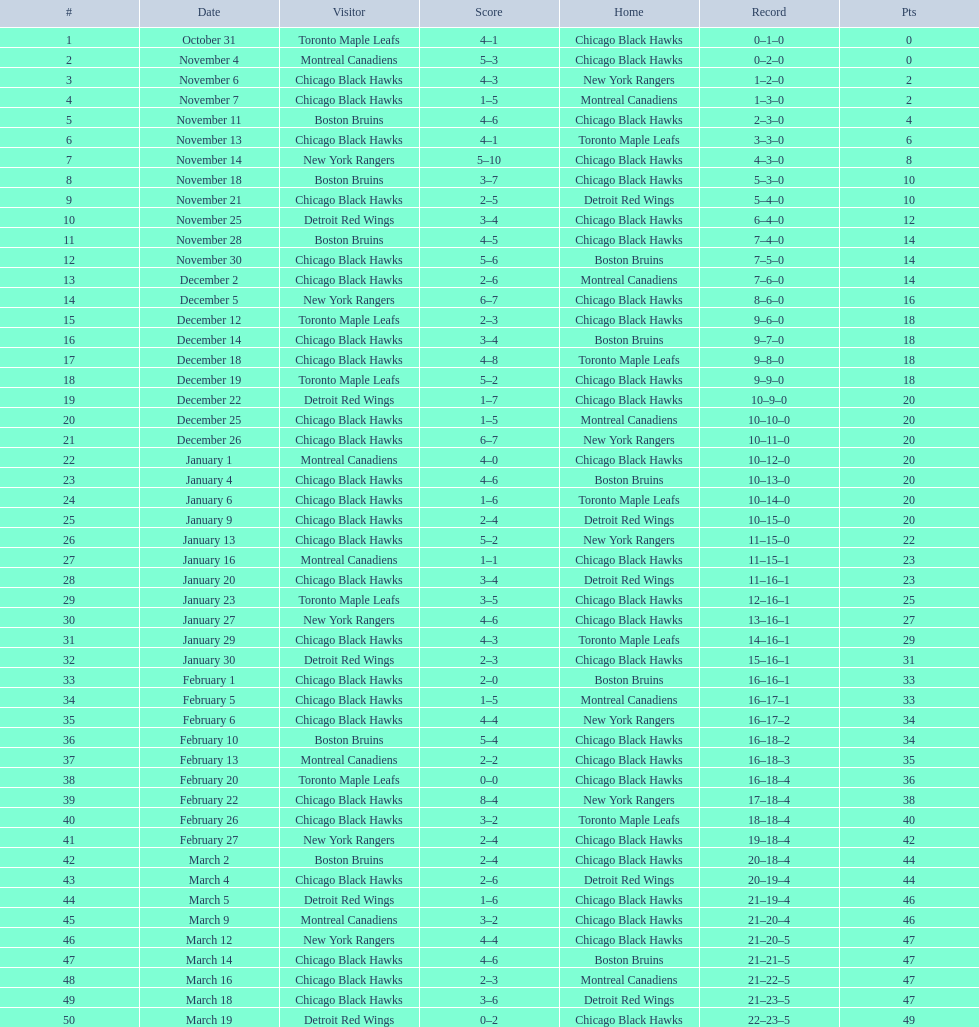How many points separated the winner and loser in the december 19th game? 3. Can you parse all the data within this table? {'header': ['#', 'Date', 'Visitor', 'Score', 'Home', 'Record', 'Pts'], 'rows': [['1', 'October 31', 'Toronto Maple Leafs', '4–1', 'Chicago Black Hawks', '0–1–0', '0'], ['2', 'November 4', 'Montreal Canadiens', '5–3', 'Chicago Black Hawks', '0–2–0', '0'], ['3', 'November 6', 'Chicago Black Hawks', '4–3', 'New York Rangers', '1–2–0', '2'], ['4', 'November 7', 'Chicago Black Hawks', '1–5', 'Montreal Canadiens', '1–3–0', '2'], ['5', 'November 11', 'Boston Bruins', '4–6', 'Chicago Black Hawks', '2–3–0', '4'], ['6', 'November 13', 'Chicago Black Hawks', '4–1', 'Toronto Maple Leafs', '3–3–0', '6'], ['7', 'November 14', 'New York Rangers', '5–10', 'Chicago Black Hawks', '4–3–0', '8'], ['8', 'November 18', 'Boston Bruins', '3–7', 'Chicago Black Hawks', '5–3–0', '10'], ['9', 'November 21', 'Chicago Black Hawks', '2–5', 'Detroit Red Wings', '5–4–0', '10'], ['10', 'November 25', 'Detroit Red Wings', '3–4', 'Chicago Black Hawks', '6–4–0', '12'], ['11', 'November 28', 'Boston Bruins', '4–5', 'Chicago Black Hawks', '7–4–0', '14'], ['12', 'November 30', 'Chicago Black Hawks', '5–6', 'Boston Bruins', '7–5–0', '14'], ['13', 'December 2', 'Chicago Black Hawks', '2–6', 'Montreal Canadiens', '7–6–0', '14'], ['14', 'December 5', 'New York Rangers', '6–7', 'Chicago Black Hawks', '8–6–0', '16'], ['15', 'December 12', 'Toronto Maple Leafs', '2–3', 'Chicago Black Hawks', '9–6–0', '18'], ['16', 'December 14', 'Chicago Black Hawks', '3–4', 'Boston Bruins', '9–7–0', '18'], ['17', 'December 18', 'Chicago Black Hawks', '4–8', 'Toronto Maple Leafs', '9–8–0', '18'], ['18', 'December 19', 'Toronto Maple Leafs', '5–2', 'Chicago Black Hawks', '9–9–0', '18'], ['19', 'December 22', 'Detroit Red Wings', '1–7', 'Chicago Black Hawks', '10–9–0', '20'], ['20', 'December 25', 'Chicago Black Hawks', '1–5', 'Montreal Canadiens', '10–10–0', '20'], ['21', 'December 26', 'Chicago Black Hawks', '6–7', 'New York Rangers', '10–11–0', '20'], ['22', 'January 1', 'Montreal Canadiens', '4–0', 'Chicago Black Hawks', '10–12–0', '20'], ['23', 'January 4', 'Chicago Black Hawks', '4–6', 'Boston Bruins', '10–13–0', '20'], ['24', 'January 6', 'Chicago Black Hawks', '1–6', 'Toronto Maple Leafs', '10–14–0', '20'], ['25', 'January 9', 'Chicago Black Hawks', '2–4', 'Detroit Red Wings', '10–15–0', '20'], ['26', 'January 13', 'Chicago Black Hawks', '5–2', 'New York Rangers', '11–15–0', '22'], ['27', 'January 16', 'Montreal Canadiens', '1–1', 'Chicago Black Hawks', '11–15–1', '23'], ['28', 'January 20', 'Chicago Black Hawks', '3–4', 'Detroit Red Wings', '11–16–1', '23'], ['29', 'January 23', 'Toronto Maple Leafs', '3–5', 'Chicago Black Hawks', '12–16–1', '25'], ['30', 'January 27', 'New York Rangers', '4–6', 'Chicago Black Hawks', '13–16–1', '27'], ['31', 'January 29', 'Chicago Black Hawks', '4–3', 'Toronto Maple Leafs', '14–16–1', '29'], ['32', 'January 30', 'Detroit Red Wings', '2–3', 'Chicago Black Hawks', '15–16–1', '31'], ['33', 'February 1', 'Chicago Black Hawks', '2–0', 'Boston Bruins', '16–16–1', '33'], ['34', 'February 5', 'Chicago Black Hawks', '1–5', 'Montreal Canadiens', '16–17–1', '33'], ['35', 'February 6', 'Chicago Black Hawks', '4–4', 'New York Rangers', '16–17–2', '34'], ['36', 'February 10', 'Boston Bruins', '5–4', 'Chicago Black Hawks', '16–18–2', '34'], ['37', 'February 13', 'Montreal Canadiens', '2–2', 'Chicago Black Hawks', '16–18–3', '35'], ['38', 'February 20', 'Toronto Maple Leafs', '0–0', 'Chicago Black Hawks', '16–18–4', '36'], ['39', 'February 22', 'Chicago Black Hawks', '8–4', 'New York Rangers', '17–18–4', '38'], ['40', 'February 26', 'Chicago Black Hawks', '3–2', 'Toronto Maple Leafs', '18–18–4', '40'], ['41', 'February 27', 'New York Rangers', '2–4', 'Chicago Black Hawks', '19–18–4', '42'], ['42', 'March 2', 'Boston Bruins', '2–4', 'Chicago Black Hawks', '20–18–4', '44'], ['43', 'March 4', 'Chicago Black Hawks', '2–6', 'Detroit Red Wings', '20–19–4', '44'], ['44', 'March 5', 'Detroit Red Wings', '1–6', 'Chicago Black Hawks', '21–19–4', '46'], ['45', 'March 9', 'Montreal Canadiens', '3–2', 'Chicago Black Hawks', '21–20–4', '46'], ['46', 'March 12', 'New York Rangers', '4–4', 'Chicago Black Hawks', '21–20–5', '47'], ['47', 'March 14', 'Chicago Black Hawks', '4–6', 'Boston Bruins', '21–21–5', '47'], ['48', 'March 16', 'Chicago Black Hawks', '2–3', 'Montreal Canadiens', '21–22–5', '47'], ['49', 'March 18', 'Chicago Black Hawks', '3–6', 'Detroit Red Wings', '21–23–5', '47'], ['50', 'March 19', 'Detroit Red Wings', '0–2', 'Chicago Black Hawks', '22–23–5', '49']]} 